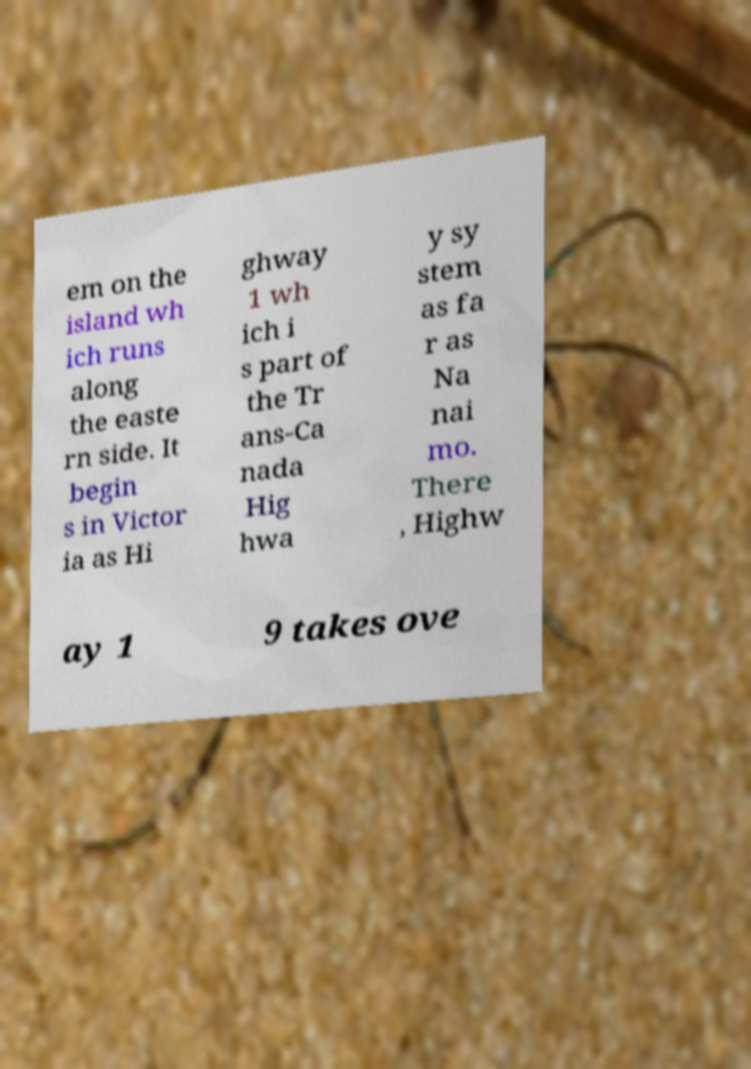There's text embedded in this image that I need extracted. Can you transcribe it verbatim? em on the island wh ich runs along the easte rn side. It begin s in Victor ia as Hi ghway 1 wh ich i s part of the Tr ans-Ca nada Hig hwa y sy stem as fa r as Na nai mo. There , Highw ay 1 9 takes ove 